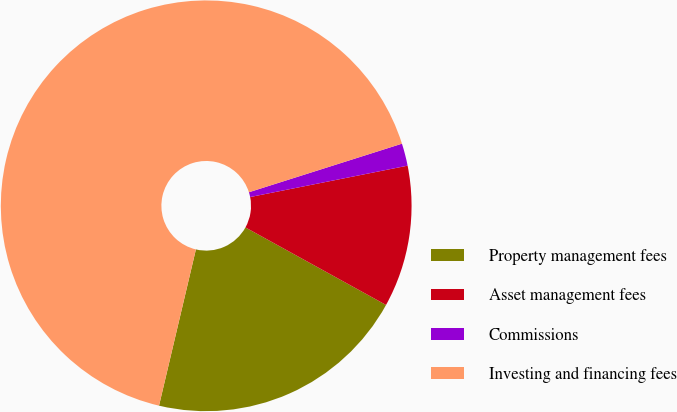Convert chart to OTSL. <chart><loc_0><loc_0><loc_500><loc_500><pie_chart><fcel>Property management fees<fcel>Asset management fees<fcel>Commissions<fcel>Investing and financing fees<nl><fcel>20.67%<fcel>11.15%<fcel>1.76%<fcel>66.42%<nl></chart> 